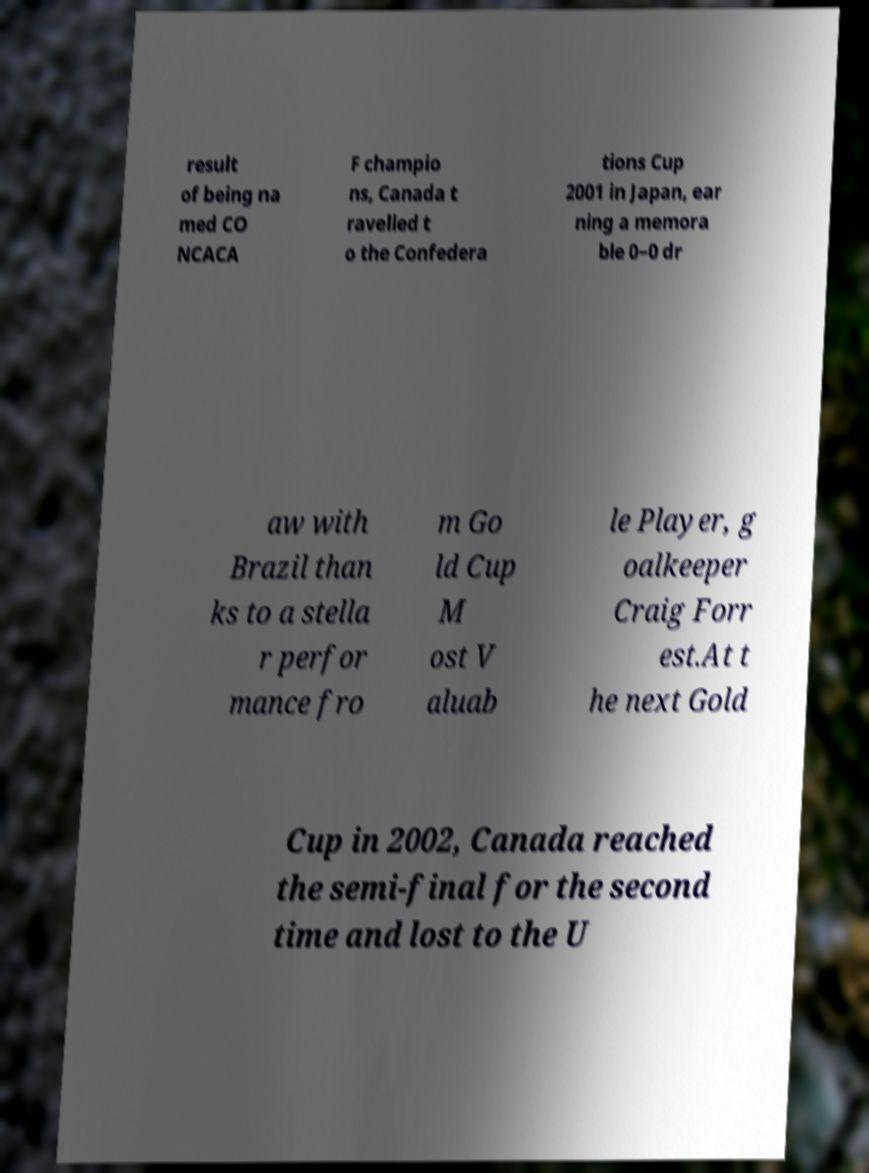What messages or text are displayed in this image? I need them in a readable, typed format. result of being na med CO NCACA F champio ns, Canada t ravelled t o the Confedera tions Cup 2001 in Japan, ear ning a memora ble 0–0 dr aw with Brazil than ks to a stella r perfor mance fro m Go ld Cup M ost V aluab le Player, g oalkeeper Craig Forr est.At t he next Gold Cup in 2002, Canada reached the semi-final for the second time and lost to the U 